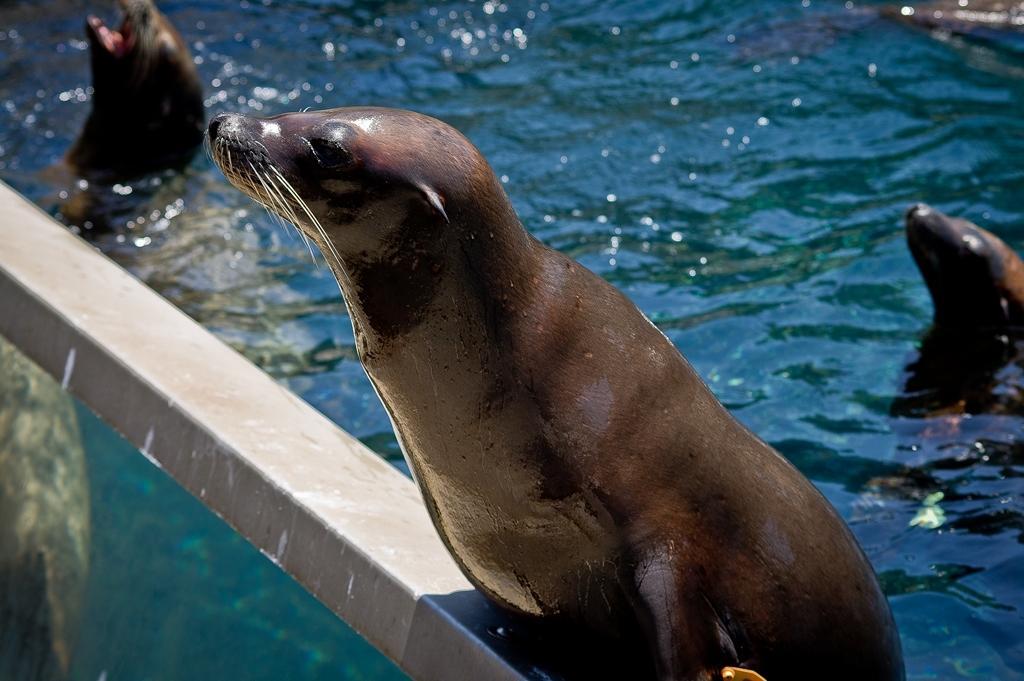Describe this image in one or two sentences. In this image, I can see a sea lion on a metal rod and there are two other sea lions in the water. 